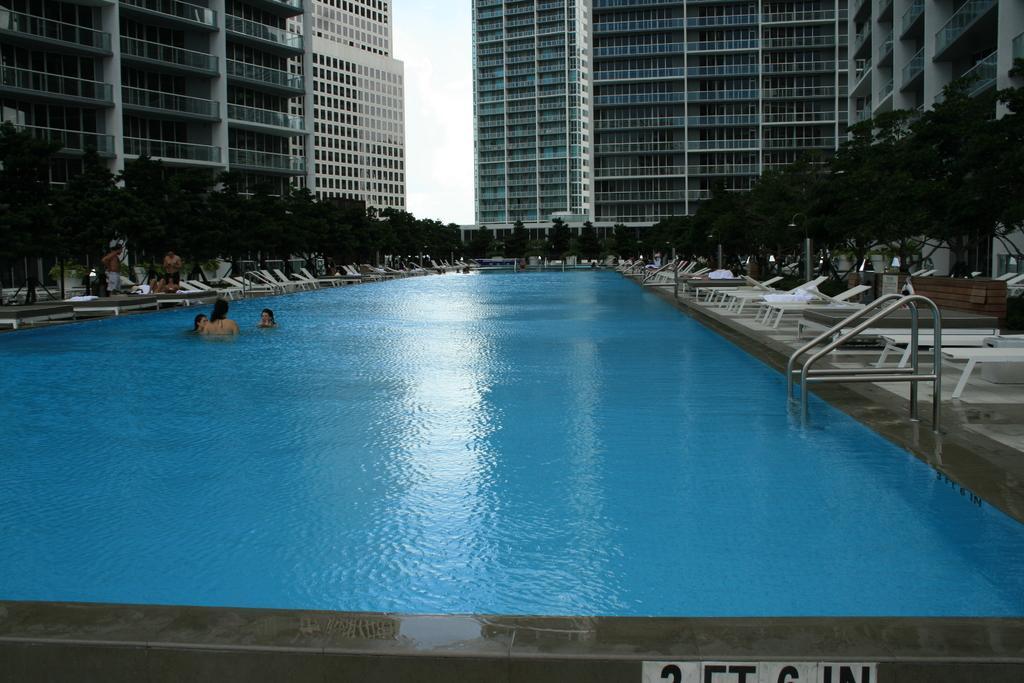Please provide a concise description of this image. In this picture there are three persons in the swimming pool. On the left side of the image there are group of people standing at the chair. On the right side of the image there are chairs and there is a handrail. At the back there are buildings and trees. At the top there is sky. At the bottom there is water. 